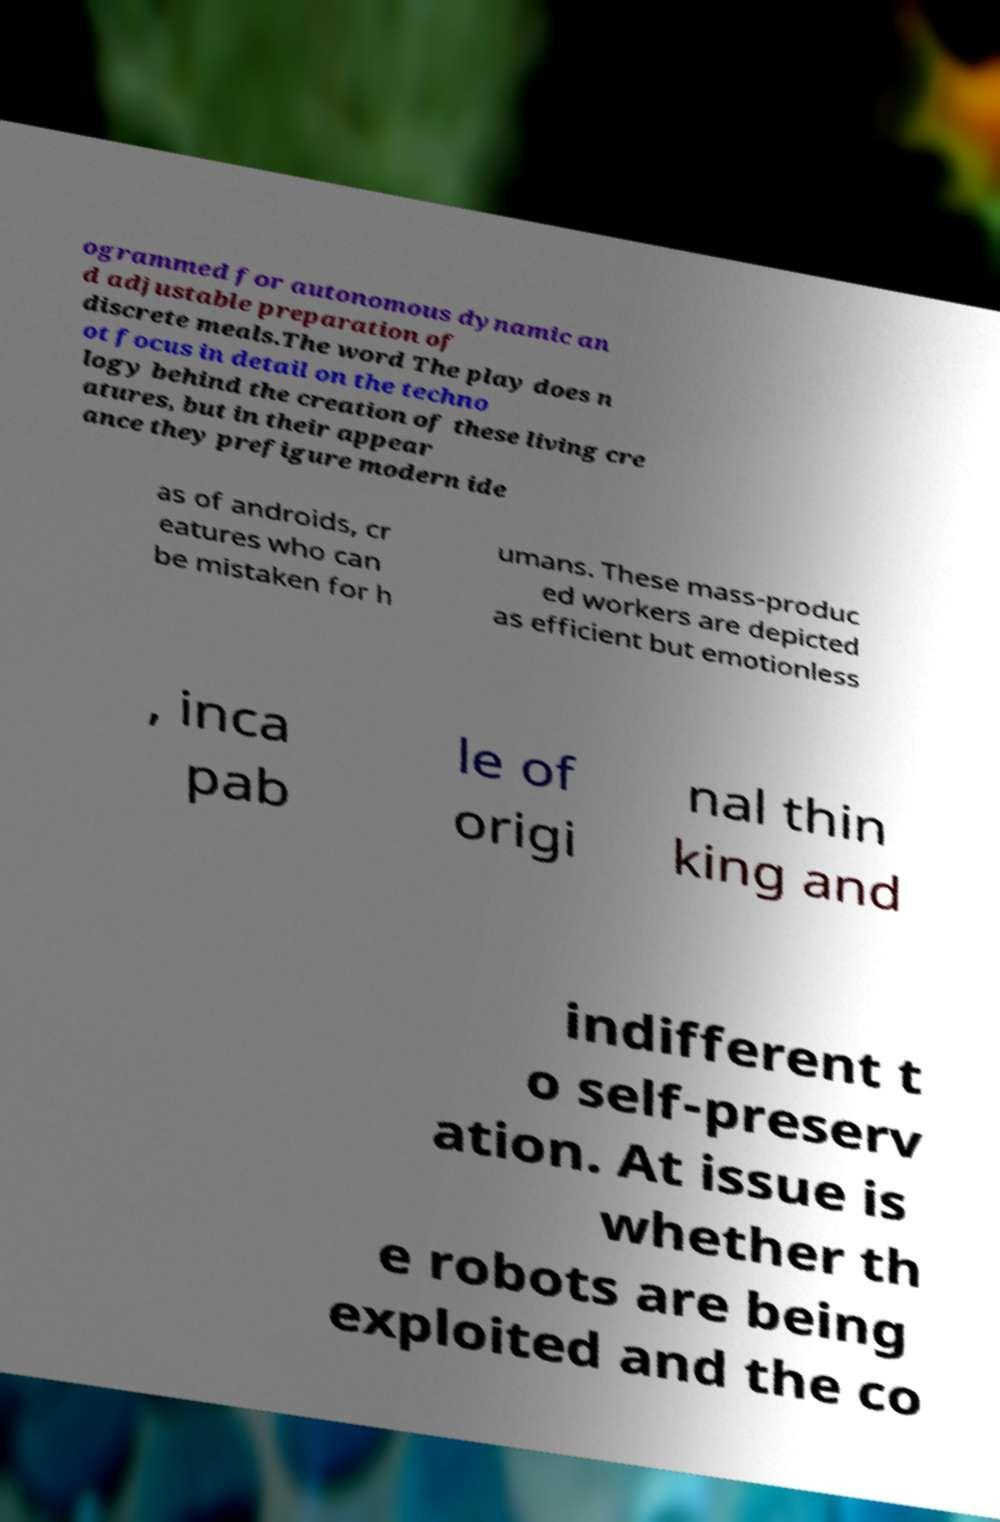Please read and relay the text visible in this image. What does it say? ogrammed for autonomous dynamic an d adjustable preparation of discrete meals.The word The play does n ot focus in detail on the techno logy behind the creation of these living cre atures, but in their appear ance they prefigure modern ide as of androids, cr eatures who can be mistaken for h umans. These mass-produc ed workers are depicted as efficient but emotionless , inca pab le of origi nal thin king and indifferent t o self-preserv ation. At issue is whether th e robots are being exploited and the co 